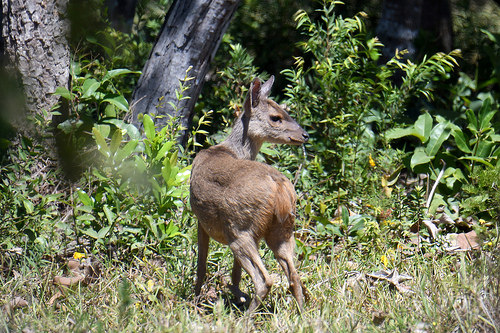<image>
Is there a deer behind the tree? No. The deer is not behind the tree. From this viewpoint, the deer appears to be positioned elsewhere in the scene. 